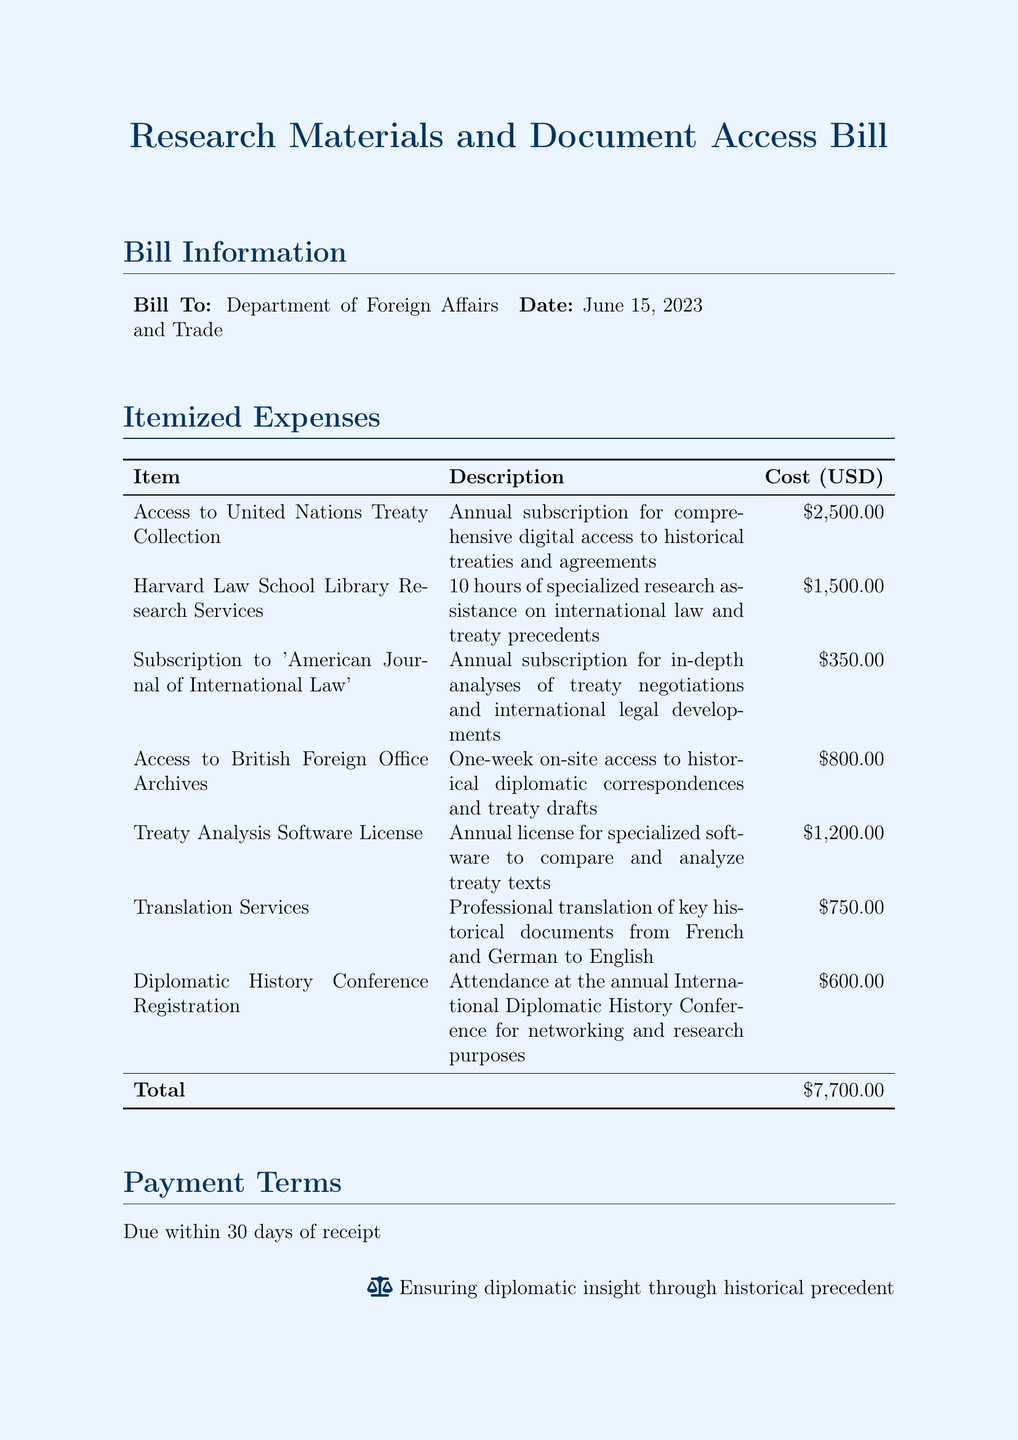What is the total cost of the bill? The total cost is listed at the end of the itemized expenses section, which sums all expenses to $7,700.00.
Answer: $7,700.00 What is the date of the bill? The date of the bill is specified in the "Bill Information" section as June 15, 2023.
Answer: June 15, 2023 Who is the bill addressed to? The recipient of the bill is indicated in the "Bill Information" section, which mentions the Department of Foreign Affairs and Trade.
Answer: Department of Foreign Affairs and Trade How many hours of research assistance were provided? It is detailed in the itemized expenses that 10 hours of specialized research assistance were purchased from Harvard Law School Library Research Services.
Answer: 10 hours What is the cost of the translation services? The cost associated with professional translation services is listed under itemized expenses as $750.00.
Answer: $750.00 What type of access is obtained from the United Nations Treaty Collection? The itemization states that it is an annual subscription for comprehensive digital access to historical treaties and agreements.
Answer: Comprehensive digital access What is the purpose of attending the Diplomatic History Conference? It is indicated that the purpose of attendance is for networking and research purposes in the itemized expenses sections.
Answer: Networking and research What is included in the research services from Harvard Law School? The description specifies that it includes 10 hours of specialized research assistance on international law and treaty precedents.
Answer: Specialized research assistance What are the payment terms for the bill? The payment terms are mentioned at the end of the document, stating that payment is due within 30 days of receipt.
Answer: Due within 30 days 